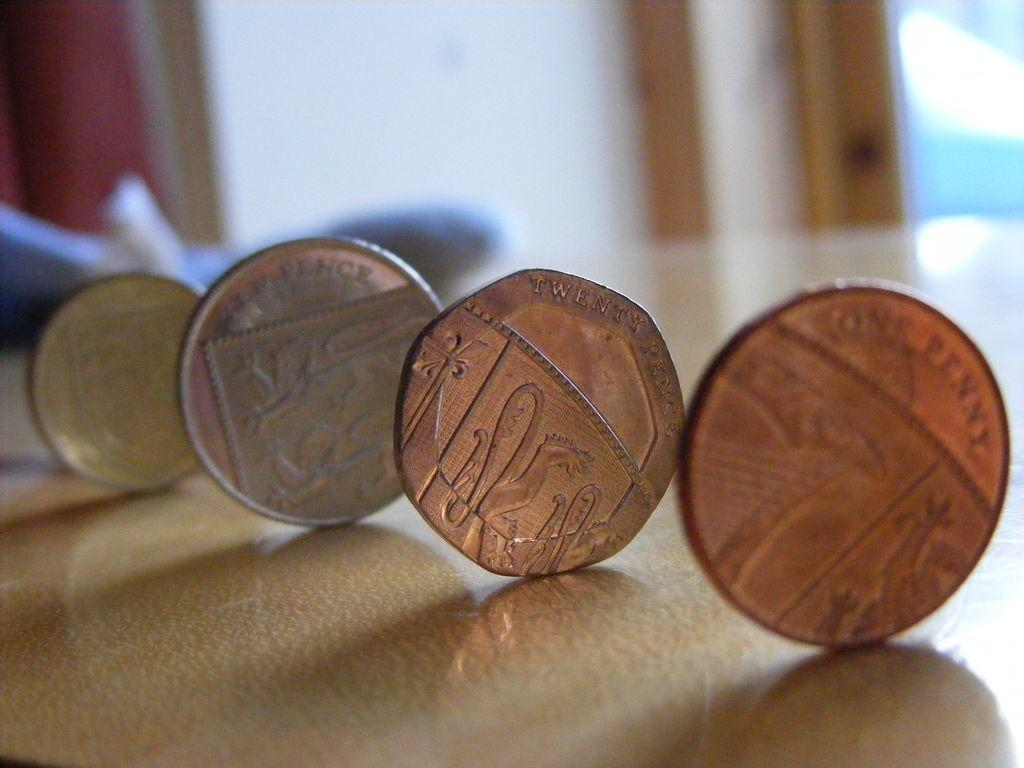<image>
Describe the image concisely. Four coins stand lined up in a row, one of which is labeled One Penny. 